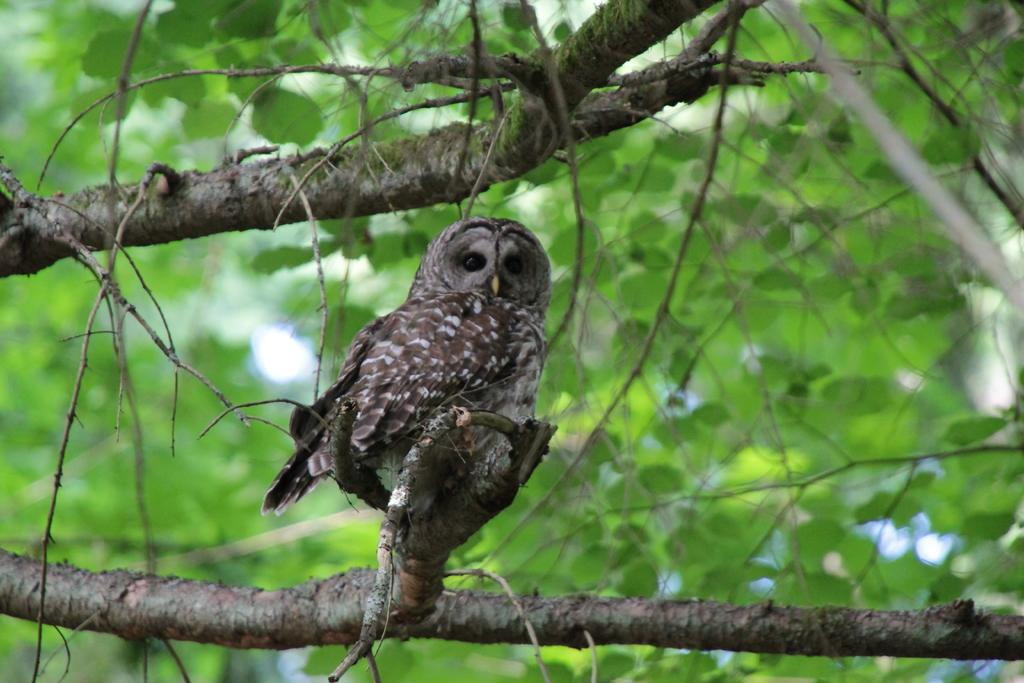What animal can be seen in the picture? There is an owl in the picture. Where is the owl located? The owl is sitting on a tree. What part of the tree can be seen in the picture? Leaves of the tree are visible in the picture. What type of clouds can be seen in the picture? There are no clouds visible in the picture; it features an owl sitting on a tree with leaves. Can you tell me how many ants are crawling on the owl's feet in the picture? There are no ants present in the picture; it only features an owl sitting on a tree with leaves. 